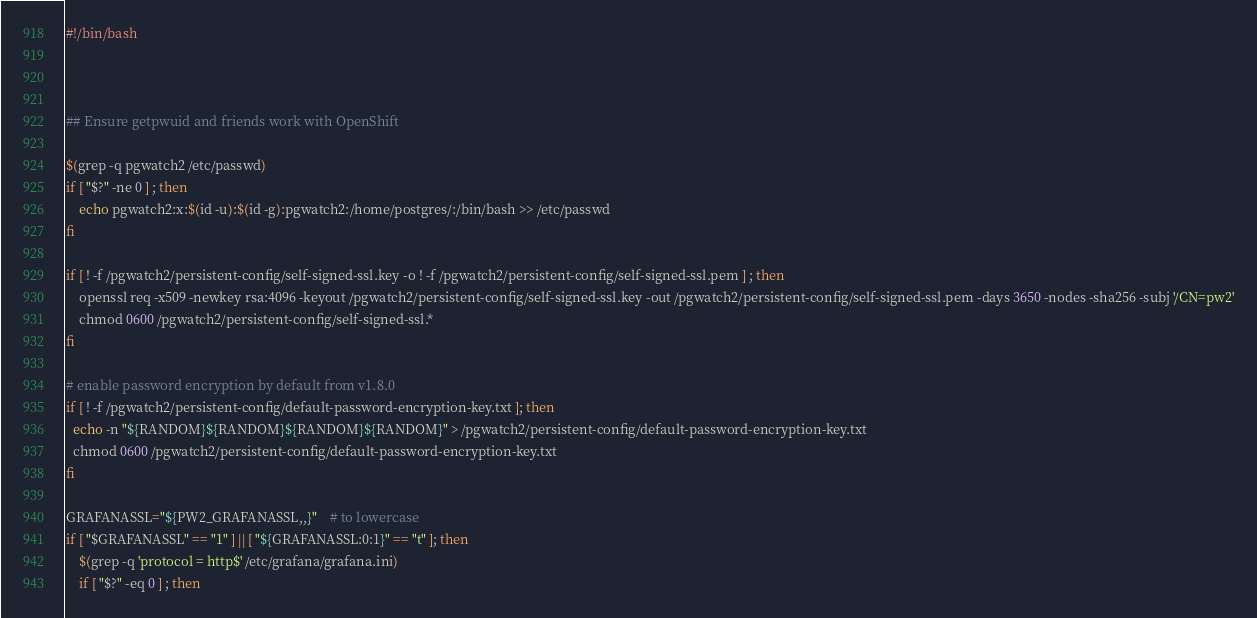<code> <loc_0><loc_0><loc_500><loc_500><_Bash_>#!/bin/bash



## Ensure getpwuid and friends work with OpenShift

$(grep -q pgwatch2 /etc/passwd)
if [ "$?" -ne 0 ] ; then
    echo pgwatch2:x:$(id -u):$(id -g):pgwatch2:/home/postgres/:/bin/bash >> /etc/passwd
fi

if [ ! -f /pgwatch2/persistent-config/self-signed-ssl.key -o ! -f /pgwatch2/persistent-config/self-signed-ssl.pem ] ; then
    openssl req -x509 -newkey rsa:4096 -keyout /pgwatch2/persistent-config/self-signed-ssl.key -out /pgwatch2/persistent-config/self-signed-ssl.pem -days 3650 -nodes -sha256 -subj '/CN=pw2'
    chmod 0600 /pgwatch2/persistent-config/self-signed-ssl.*
fi

# enable password encryption by default from v1.8.0
if [ ! -f /pgwatch2/persistent-config/default-password-encryption-key.txt ]; then
  echo -n "${RANDOM}${RANDOM}${RANDOM}${RANDOM}" > /pgwatch2/persistent-config/default-password-encryption-key.txt
  chmod 0600 /pgwatch2/persistent-config/default-password-encryption-key.txt
fi

GRAFANASSL="${PW2_GRAFANASSL,,}"    # to lowercase
if [ "$GRAFANASSL" == "1" ] || [ "${GRAFANASSL:0:1}" == "t" ]; then
    $(grep -q 'protocol = http$' /etc/grafana/grafana.ini)
    if [ "$?" -eq 0 ] ; then</code> 